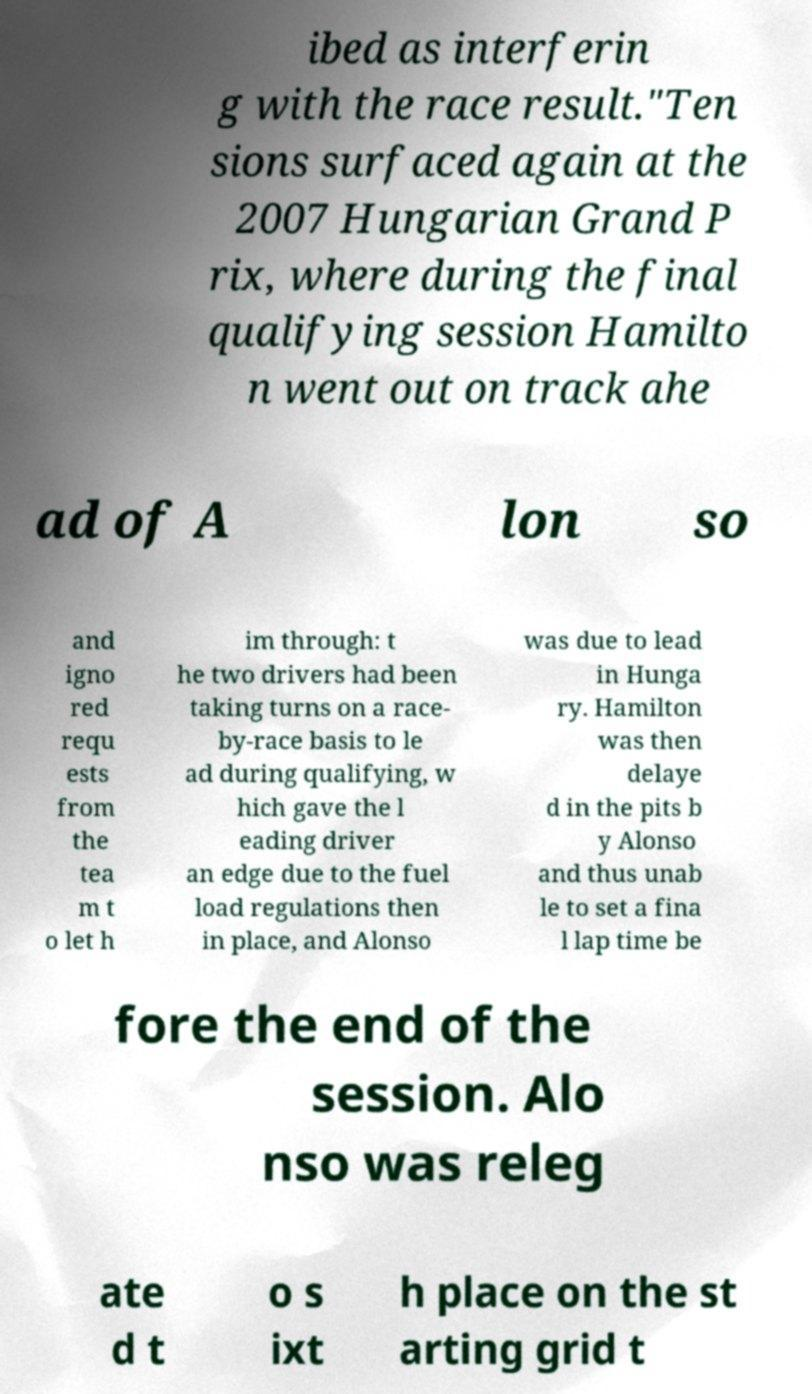Can you accurately transcribe the text from the provided image for me? ibed as interferin g with the race result."Ten sions surfaced again at the 2007 Hungarian Grand P rix, where during the final qualifying session Hamilto n went out on track ahe ad of A lon so and igno red requ ests from the tea m t o let h im through: t he two drivers had been taking turns on a race- by-race basis to le ad during qualifying, w hich gave the l eading driver an edge due to the fuel load regulations then in place, and Alonso was due to lead in Hunga ry. Hamilton was then delaye d in the pits b y Alonso and thus unab le to set a fina l lap time be fore the end of the session. Alo nso was releg ate d t o s ixt h place on the st arting grid t 